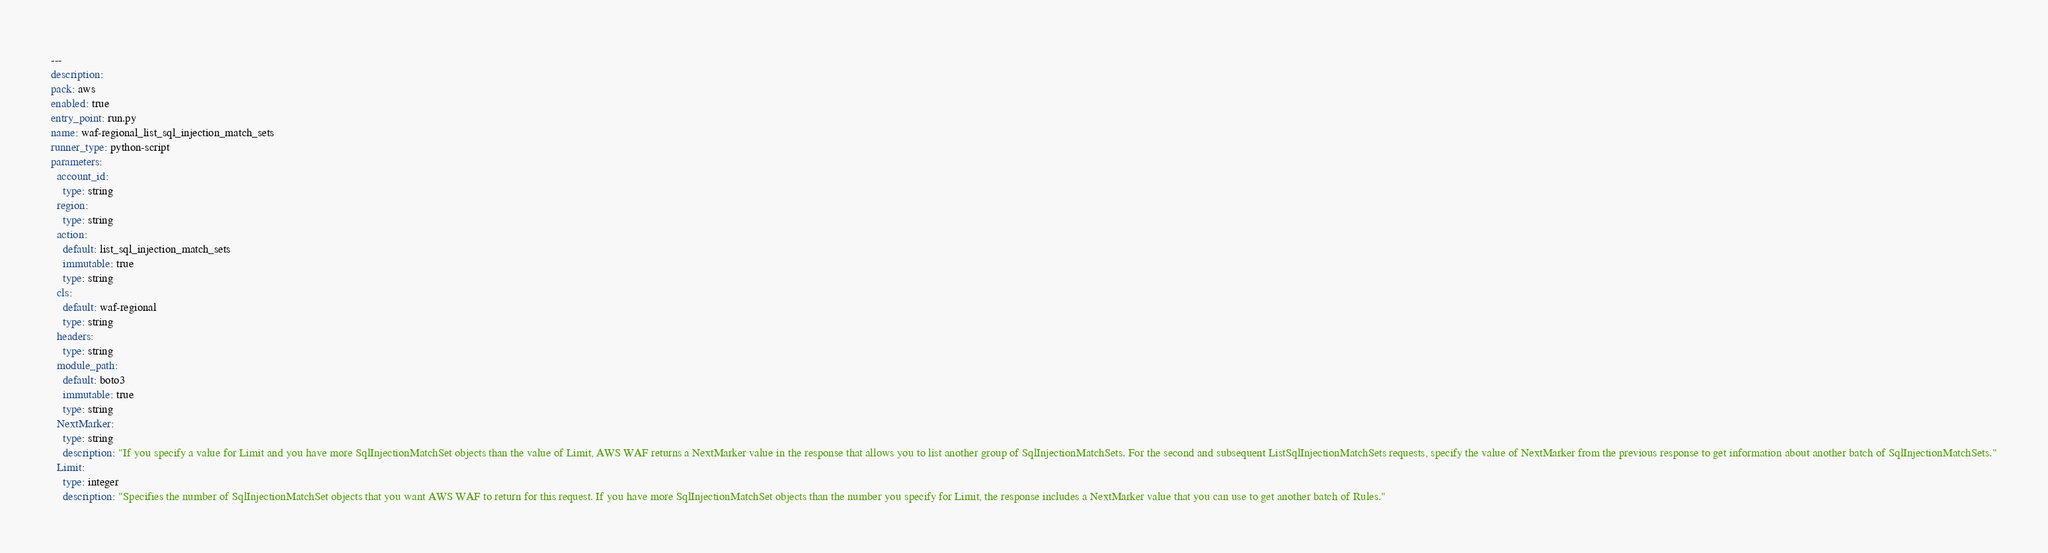<code> <loc_0><loc_0><loc_500><loc_500><_YAML_>---
description: 
pack: aws
enabled: true
entry_point: run.py
name: waf-regional_list_sql_injection_match_sets
runner_type: python-script
parameters:
  account_id:
    type: string
  region:
    type: string
  action:
    default: list_sql_injection_match_sets
    immutable: true
    type: string
  cls:
    default: waf-regional
    type: string
  headers:
    type: string
  module_path:
    default: boto3
    immutable: true
    type: string
  NextMarker:
    type: string
    description: "If you specify a value for Limit and you have more SqlInjectionMatchSet objects than the value of Limit, AWS WAF returns a NextMarker value in the response that allows you to list another group of SqlInjectionMatchSets. For the second and subsequent ListSqlInjectionMatchSets requests, specify the value of NextMarker from the previous response to get information about another batch of SqlInjectionMatchSets."
  Limit:
    type: integer
    description: "Specifies the number of SqlInjectionMatchSet objects that you want AWS WAF to return for this request. If you have more SqlInjectionMatchSet objects than the number you specify for Limit, the response includes a NextMarker value that you can use to get another batch of Rules."</code> 